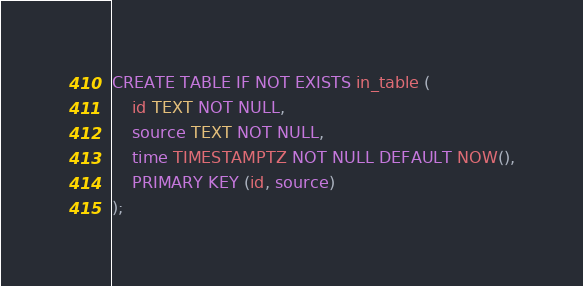Convert code to text. <code><loc_0><loc_0><loc_500><loc_500><_SQL_>CREATE TABLE IF NOT EXISTS in_table (
    id TEXT NOT NULL,
    source TEXT NOT NULL,
    time TIMESTAMPTZ NOT NULL DEFAULT NOW(),
    PRIMARY KEY (id, source)
);
</code> 